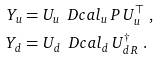<formula> <loc_0><loc_0><loc_500><loc_500>Y _ { u } & = U _ { u } \, \ D c a l _ { u } \, P \, U _ { u } ^ { \top } \ , \\ Y _ { d } & = U _ { d } \, \ D c a l _ { d } \, U _ { d \, R } ^ { \dagger } \ .</formula> 